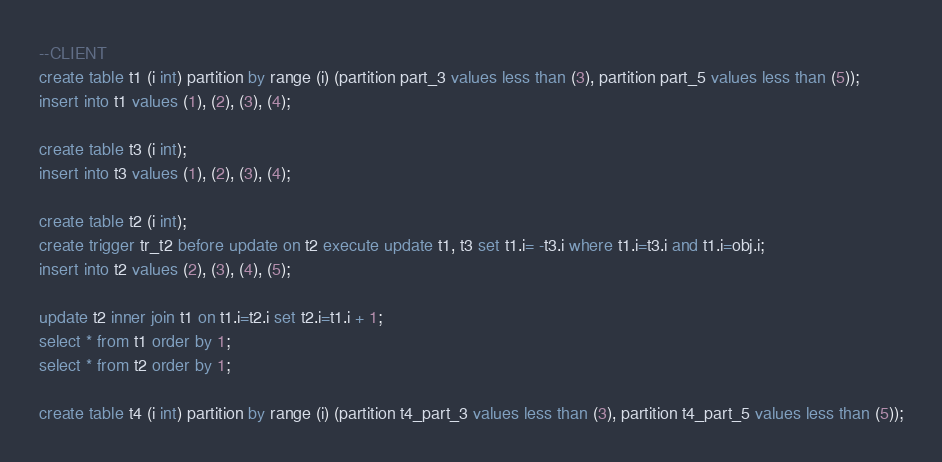Convert code to text. <code><loc_0><loc_0><loc_500><loc_500><_SQL_>--CLIENT
create table t1 (i int) partition by range (i) (partition part_3 values less than (3), partition part_5 values less than (5));
insert into t1 values (1), (2), (3), (4);

create table t3 (i int);
insert into t3 values (1), (2), (3), (4);

create table t2 (i int);
create trigger tr_t2 before update on t2 execute update t1, t3 set t1.i= -t3.i where t1.i=t3.i and t1.i=obj.i;
insert into t2 values (2), (3), (4), (5);

update t2 inner join t1 on t1.i=t2.i set t2.i=t1.i + 1;
select * from t1 order by 1;
select * from t2 order by 1;

create table t4 (i int) partition by range (i) (partition t4_part_3 values less than (3), partition t4_part_5 values less than (5));</code> 